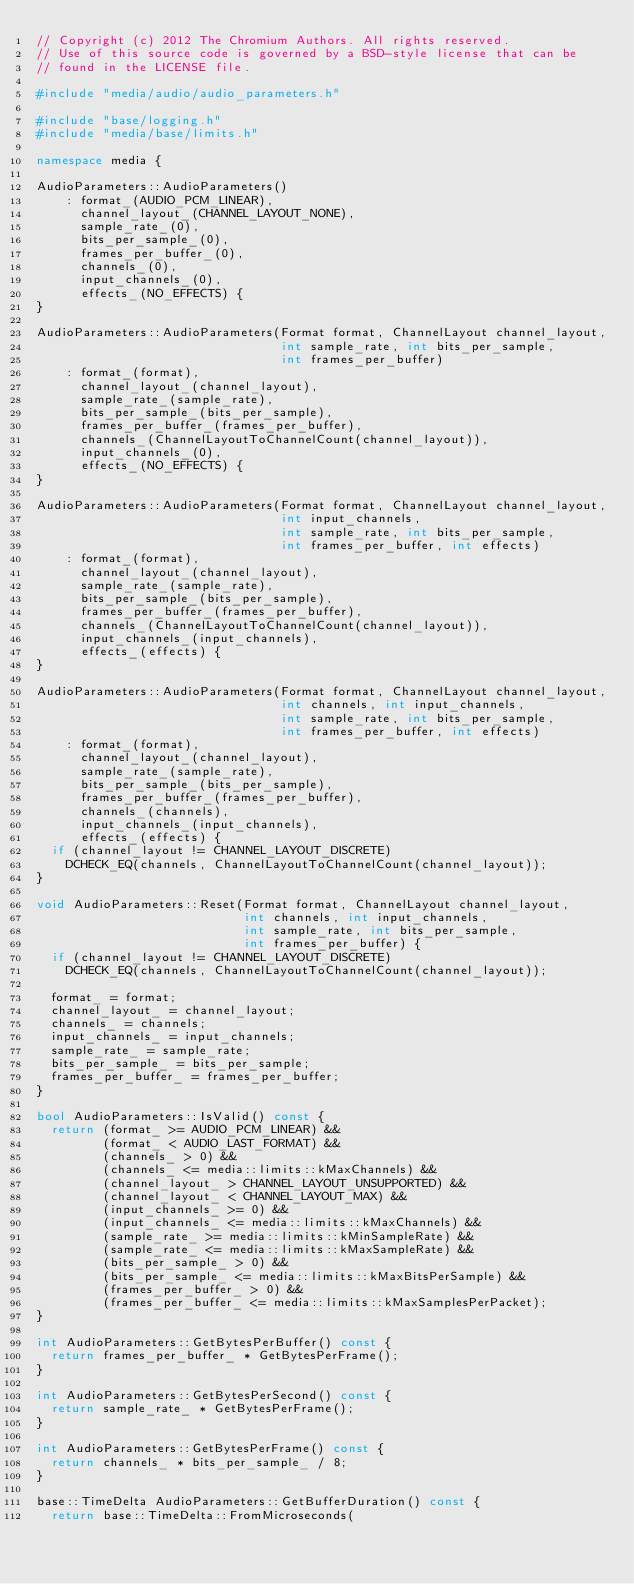Convert code to text. <code><loc_0><loc_0><loc_500><loc_500><_C++_>// Copyright (c) 2012 The Chromium Authors. All rights reserved.
// Use of this source code is governed by a BSD-style license that can be
// found in the LICENSE file.

#include "media/audio/audio_parameters.h"

#include "base/logging.h"
#include "media/base/limits.h"

namespace media {

AudioParameters::AudioParameters()
    : format_(AUDIO_PCM_LINEAR),
      channel_layout_(CHANNEL_LAYOUT_NONE),
      sample_rate_(0),
      bits_per_sample_(0),
      frames_per_buffer_(0),
      channels_(0),
      input_channels_(0),
      effects_(NO_EFFECTS) {
}

AudioParameters::AudioParameters(Format format, ChannelLayout channel_layout,
                                 int sample_rate, int bits_per_sample,
                                 int frames_per_buffer)
    : format_(format),
      channel_layout_(channel_layout),
      sample_rate_(sample_rate),
      bits_per_sample_(bits_per_sample),
      frames_per_buffer_(frames_per_buffer),
      channels_(ChannelLayoutToChannelCount(channel_layout)),
      input_channels_(0),
      effects_(NO_EFFECTS) {
}

AudioParameters::AudioParameters(Format format, ChannelLayout channel_layout,
                                 int input_channels,
                                 int sample_rate, int bits_per_sample,
                                 int frames_per_buffer, int effects)
    : format_(format),
      channel_layout_(channel_layout),
      sample_rate_(sample_rate),
      bits_per_sample_(bits_per_sample),
      frames_per_buffer_(frames_per_buffer),
      channels_(ChannelLayoutToChannelCount(channel_layout)),
      input_channels_(input_channels),
      effects_(effects) {
}

AudioParameters::AudioParameters(Format format, ChannelLayout channel_layout,
                                 int channels, int input_channels,
                                 int sample_rate, int bits_per_sample,
                                 int frames_per_buffer, int effects)
    : format_(format),
      channel_layout_(channel_layout),
      sample_rate_(sample_rate),
      bits_per_sample_(bits_per_sample),
      frames_per_buffer_(frames_per_buffer),
      channels_(channels),
      input_channels_(input_channels),
      effects_(effects) {
  if (channel_layout != CHANNEL_LAYOUT_DISCRETE)
    DCHECK_EQ(channels, ChannelLayoutToChannelCount(channel_layout));
}

void AudioParameters::Reset(Format format, ChannelLayout channel_layout,
                            int channels, int input_channels,
                            int sample_rate, int bits_per_sample,
                            int frames_per_buffer) {
  if (channel_layout != CHANNEL_LAYOUT_DISCRETE)
    DCHECK_EQ(channels, ChannelLayoutToChannelCount(channel_layout));

  format_ = format;
  channel_layout_ = channel_layout;
  channels_ = channels;
  input_channels_ = input_channels;
  sample_rate_ = sample_rate;
  bits_per_sample_ = bits_per_sample;
  frames_per_buffer_ = frames_per_buffer;
}

bool AudioParameters::IsValid() const {
  return (format_ >= AUDIO_PCM_LINEAR) &&
         (format_ < AUDIO_LAST_FORMAT) &&
         (channels_ > 0) &&
         (channels_ <= media::limits::kMaxChannels) &&
         (channel_layout_ > CHANNEL_LAYOUT_UNSUPPORTED) &&
         (channel_layout_ < CHANNEL_LAYOUT_MAX) &&
         (input_channels_ >= 0) &&
         (input_channels_ <= media::limits::kMaxChannels) &&
         (sample_rate_ >= media::limits::kMinSampleRate) &&
         (sample_rate_ <= media::limits::kMaxSampleRate) &&
         (bits_per_sample_ > 0) &&
         (bits_per_sample_ <= media::limits::kMaxBitsPerSample) &&
         (frames_per_buffer_ > 0) &&
         (frames_per_buffer_ <= media::limits::kMaxSamplesPerPacket);
}

int AudioParameters::GetBytesPerBuffer() const {
  return frames_per_buffer_ * GetBytesPerFrame();
}

int AudioParameters::GetBytesPerSecond() const {
  return sample_rate_ * GetBytesPerFrame();
}

int AudioParameters::GetBytesPerFrame() const {
  return channels_ * bits_per_sample_ / 8;
}

base::TimeDelta AudioParameters::GetBufferDuration() const {
  return base::TimeDelta::FromMicroseconds(</code> 